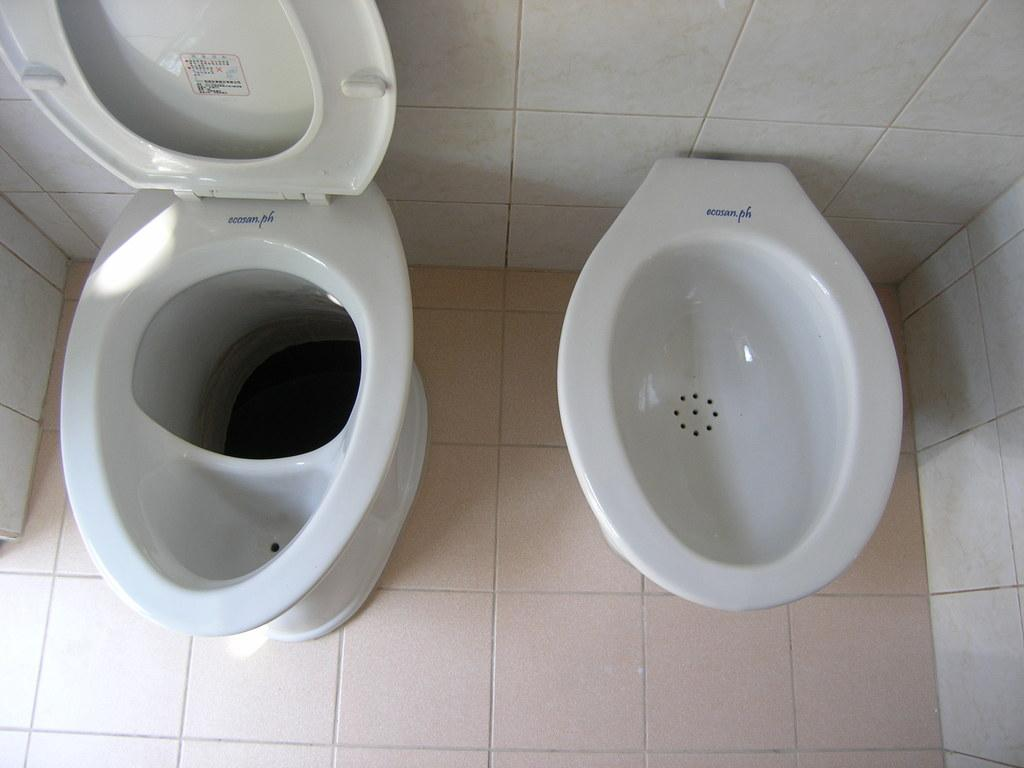What type of fixture is present in the image? There is a toilet and an urinal in the image. Where are the toilet and urinal located in the image? Both the toilet and urinal are on the floor in the image. What year is depicted in the image? The image does not depict a specific year; it only shows a toilet and an urinal on the floor. What is the sister doing in the image? There is no sister present in the image. 